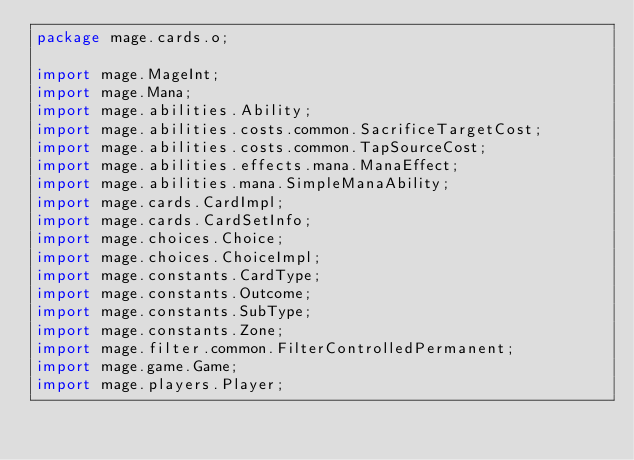Convert code to text. <code><loc_0><loc_0><loc_500><loc_500><_Java_>package mage.cards.o;

import mage.MageInt;
import mage.Mana;
import mage.abilities.Ability;
import mage.abilities.costs.common.SacrificeTargetCost;
import mage.abilities.costs.common.TapSourceCost;
import mage.abilities.effects.mana.ManaEffect;
import mage.abilities.mana.SimpleManaAbility;
import mage.cards.CardImpl;
import mage.cards.CardSetInfo;
import mage.choices.Choice;
import mage.choices.ChoiceImpl;
import mage.constants.CardType;
import mage.constants.Outcome;
import mage.constants.SubType;
import mage.constants.Zone;
import mage.filter.common.FilterControlledPermanent;
import mage.game.Game;
import mage.players.Player;</code> 